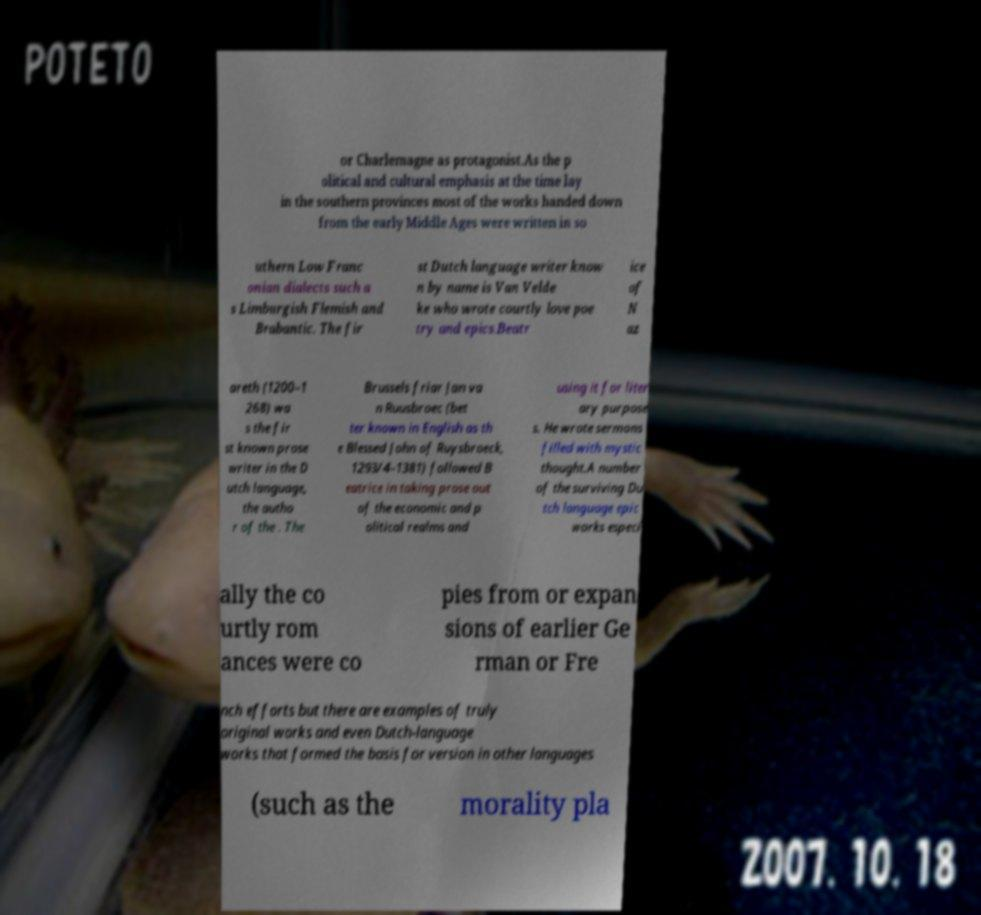Can you read and provide the text displayed in the image?This photo seems to have some interesting text. Can you extract and type it out for me? or Charlemagne as protagonist.As the p olitical and cultural emphasis at the time lay in the southern provinces most of the works handed down from the early Middle Ages were written in so uthern Low Franc onian dialects such a s Limburgish Flemish and Brabantic. The fir st Dutch language writer know n by name is Van Velde ke who wrote courtly love poe try and epics.Beatr ice of N az areth (1200–1 268) wa s the fir st known prose writer in the D utch language, the autho r of the . The Brussels friar Jan va n Ruusbroec (bet ter known in English as th e Blessed John of Ruysbroeck, 1293/4–1381) followed B eatrice in taking prose out of the economic and p olitical realms and using it for liter ary purpose s. He wrote sermons filled with mystic thought.A number of the surviving Du tch language epic works especi ally the co urtly rom ances were co pies from or expan sions of earlier Ge rman or Fre nch efforts but there are examples of truly original works and even Dutch-language works that formed the basis for version in other languages (such as the morality pla 